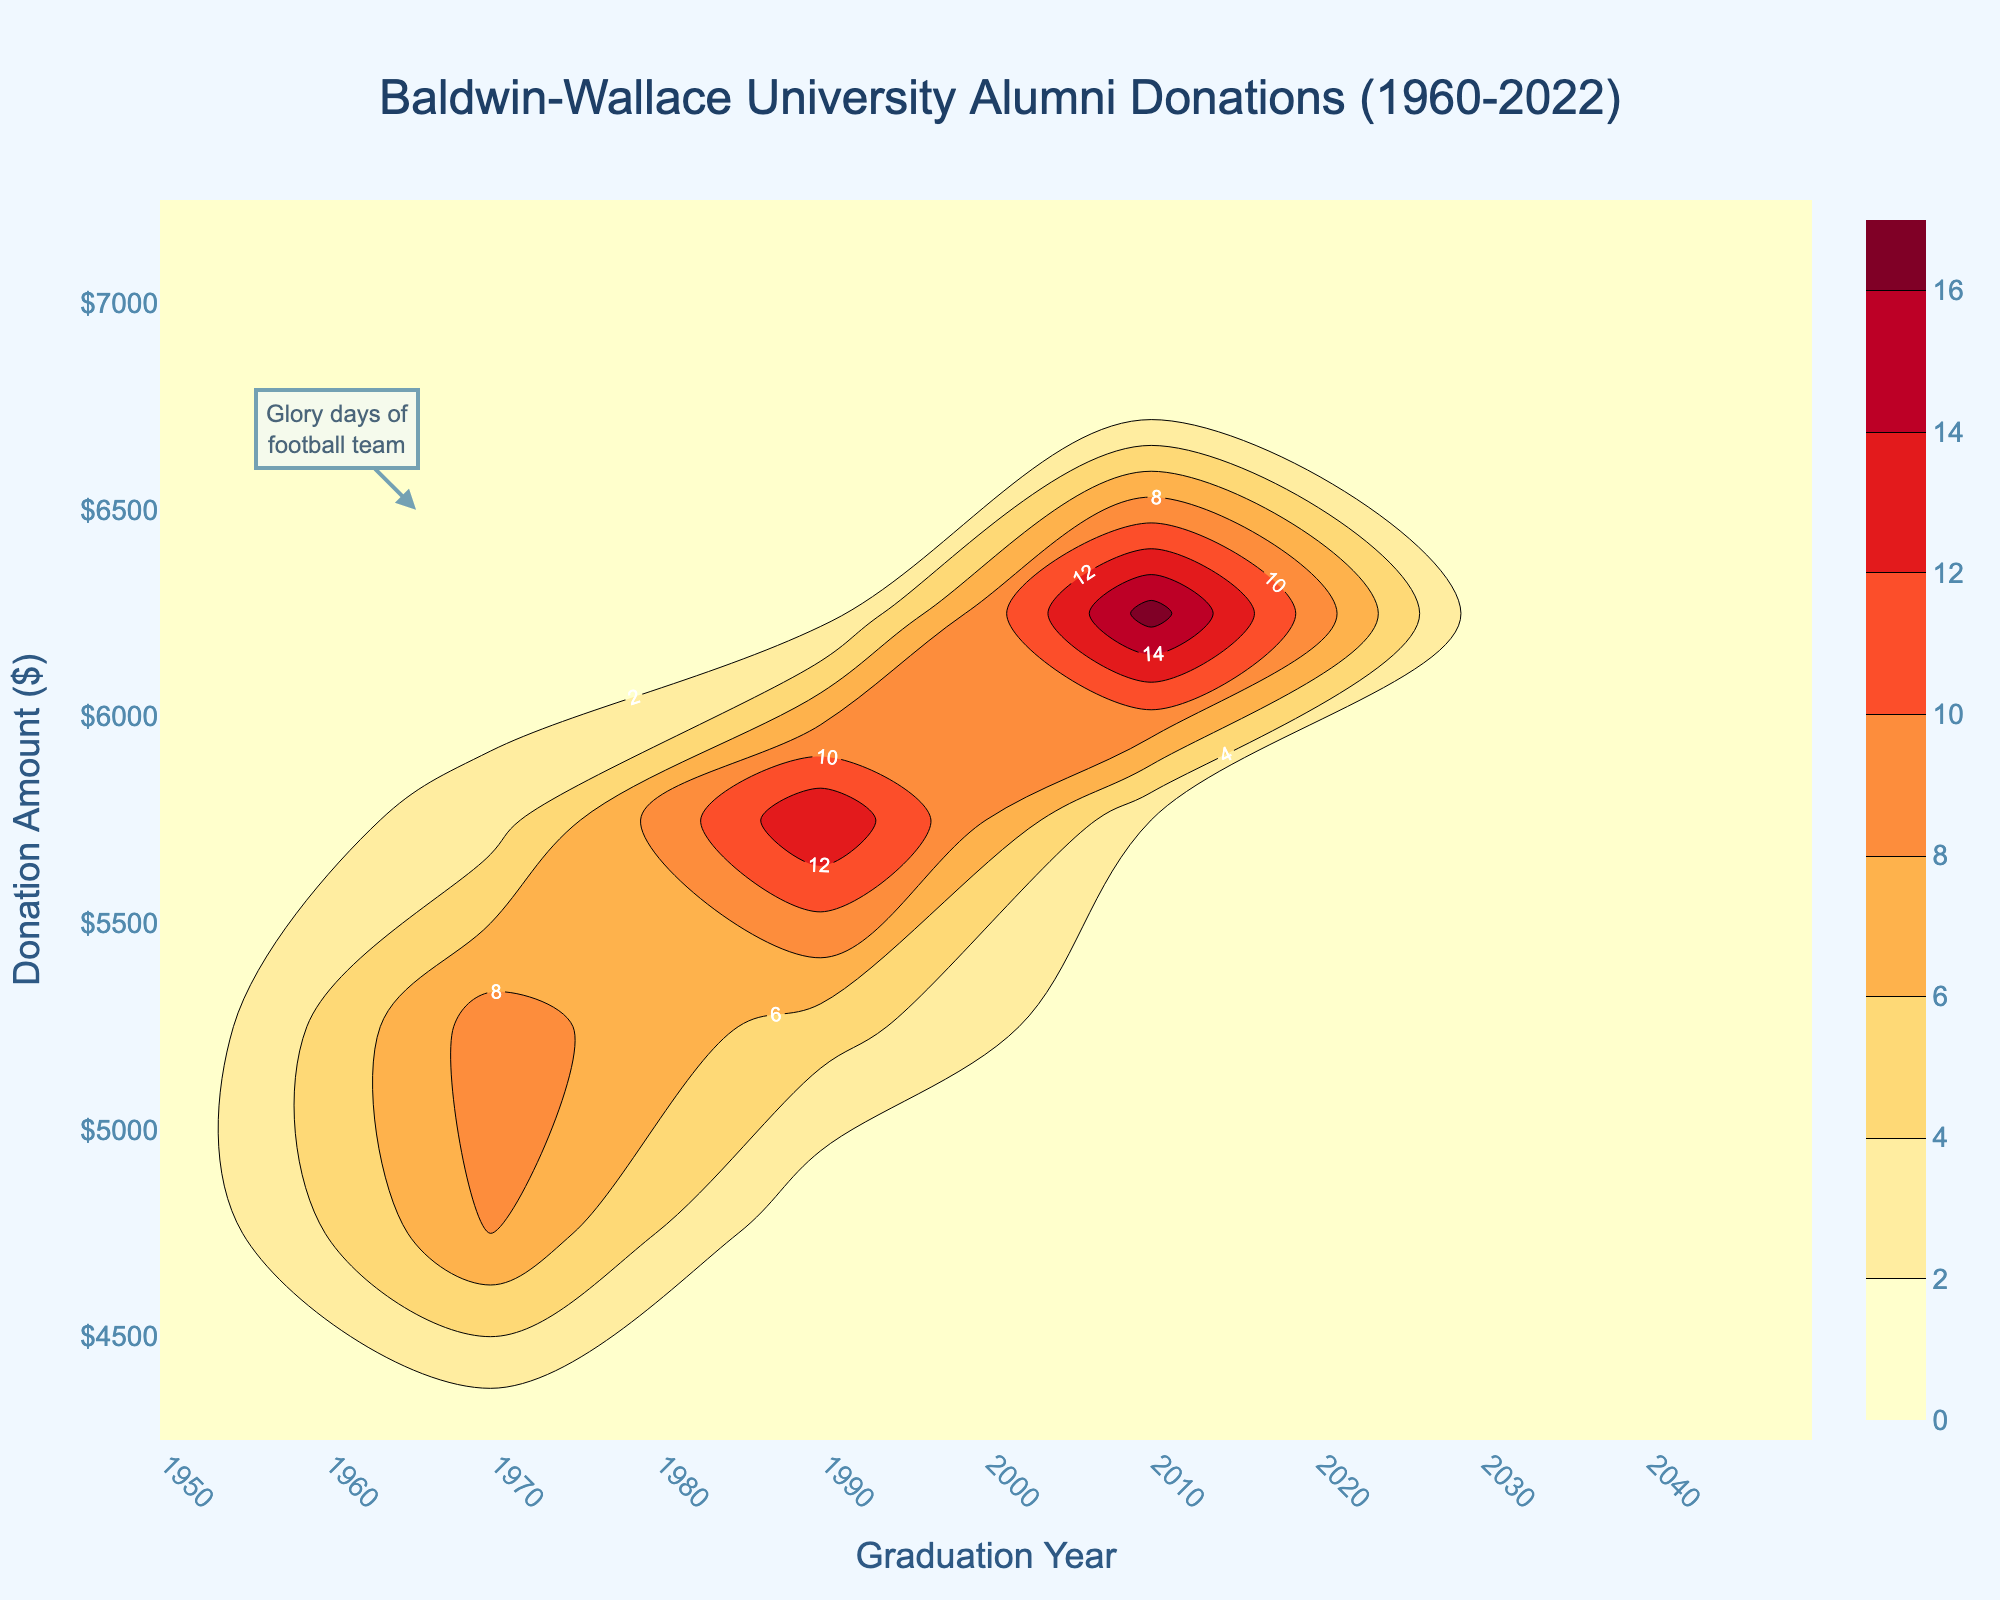What is the title of the plot? The title can be easily found at the top of the plot which states the main topic of the figure.
Answer: Baldwin-Wallace University Alumni Donations (1960-2022) What are the x and y-axis titles? The axis titles are located along the respective axes, with the x-axis and y-axis titles providing context to the data being displayed.
Answer: Graduation Year and Donation Amount ($) Between which years did the alumni make the largest donations according to the plot? By examining the contour lines and density, the years with the highest alumni donations will have higher values indicated by the contour.
Answer: 2010-2022 Describe the color pattern used in the plot. The color pattern helps to visually represent different levels of donation amounts. The gradient goes from a lighter shade to a darker orange-red tone associated with higher values.
Answer: Lighter to darker orange-red Which specific annotation is noted in the plot, and what does it refer to? This annotation is usually marked with an arrow and text box, highlighting a specific data point or period of interest.
Answer: Glory days of the football team In what year is the lowest donation amount seen? Look for the contour lines representing the lowest values; the year they are located at will be the answer.
Answer: 1961 How did donation amounts change from 1960 to 1965? Follow the contour line values from 1960 to 1965 to observe the trend in donation amounts over the specified years.
Answer: Increased Which years show the steepest increase in donation amounts? Identify the years where contour lines are closely packed, indicating a rapid change.
Answer: 2000-2004 Compare donation amounts in 1970 and 2000. Which year had higher donations? Locate the contour lines for the years 1970 and 2000 and compare the values indicated.
Answer: 2000 What's the approximate donation amount in the years 1995 and 2005? Identify the contour line values for the respective years and approximate the donation amounts.
Answer: Around $5500 and $6000 respectively 